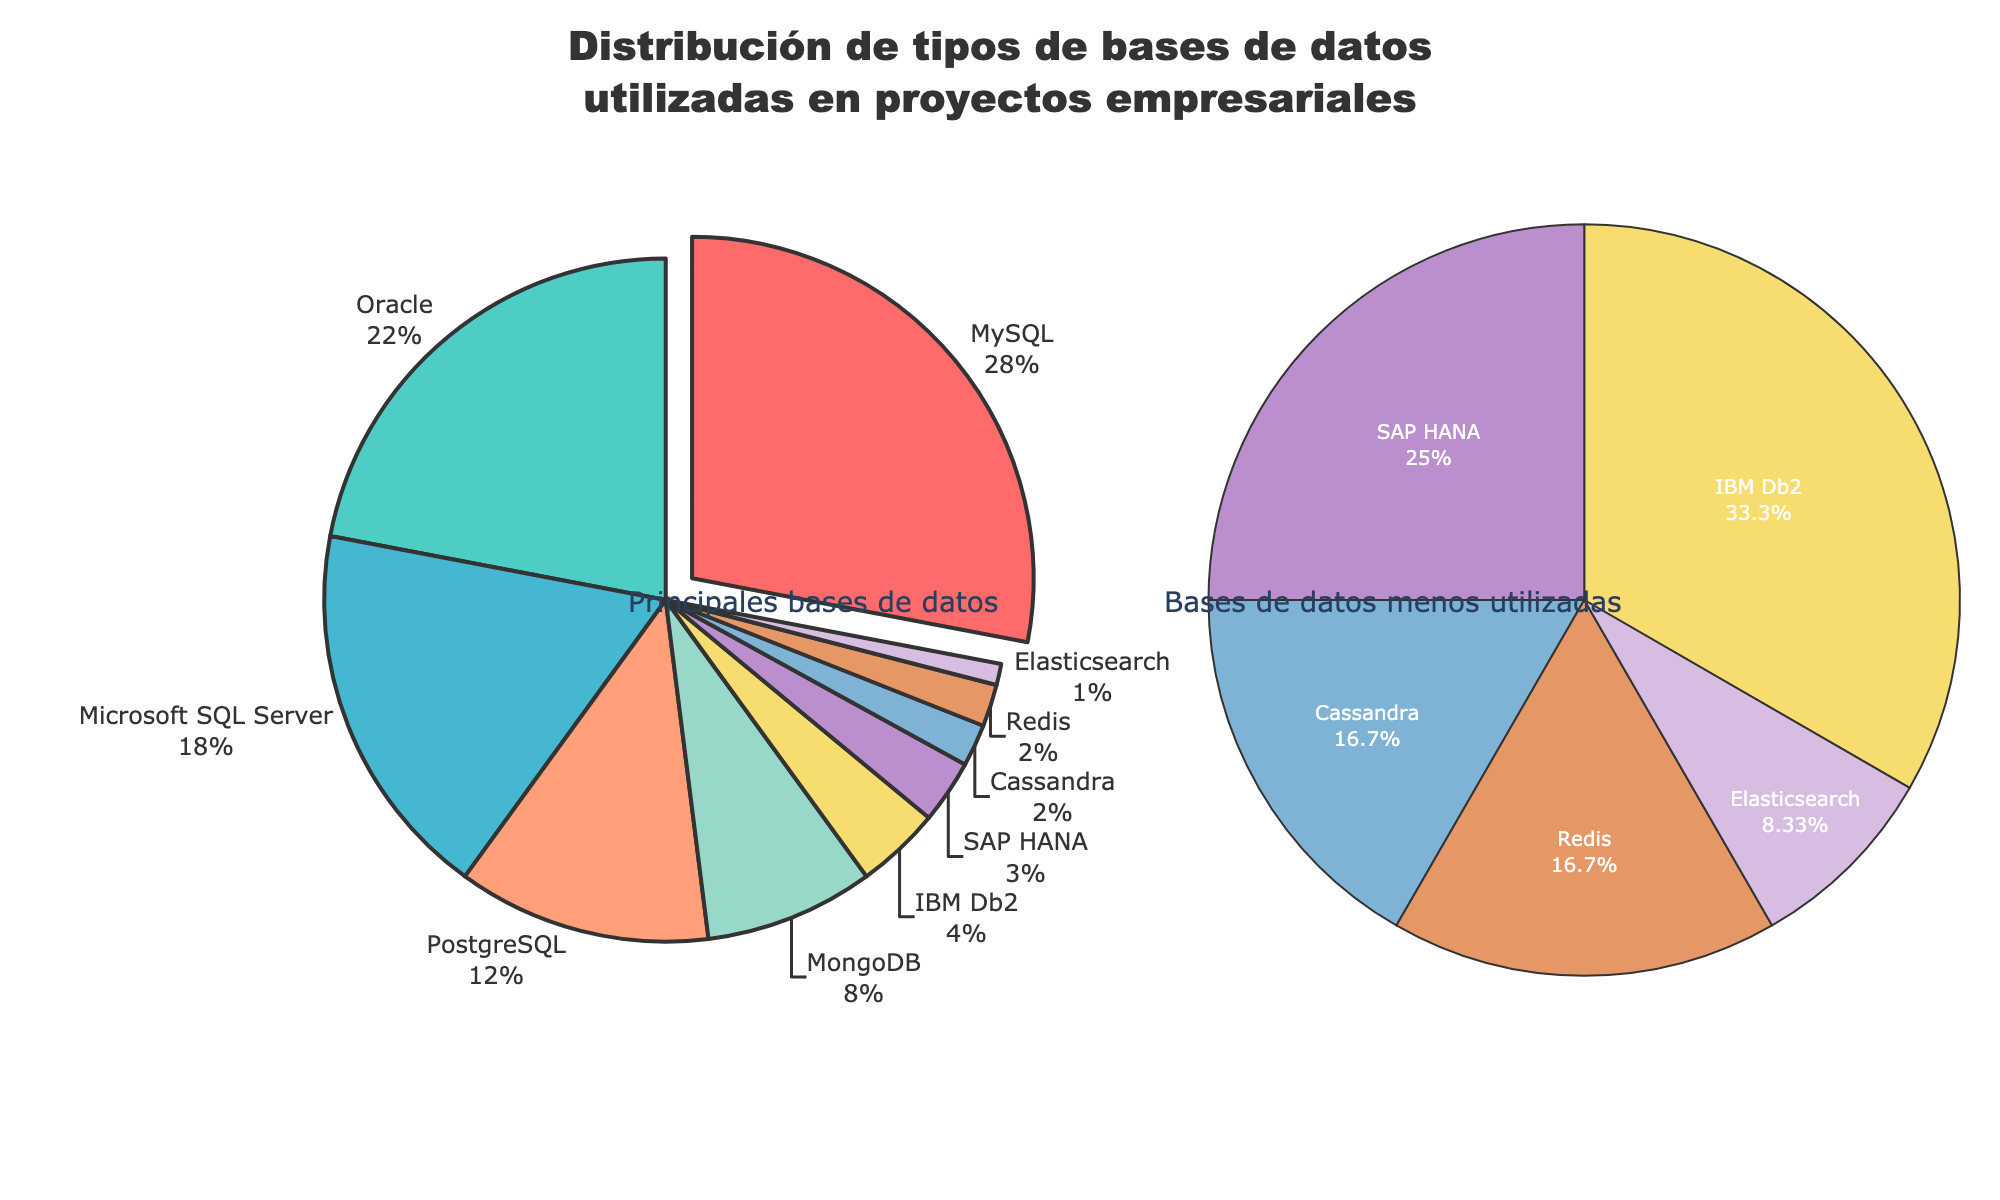¿Cuál es el tipo de base de datos más utilizado? Primero, observo los segmentos del gráfico de pastel. El segmento con mayor tamaño y una pequeña extracción es "MySQL". También se puede observar en la etiqueta que muestra "28%" que es el valor más alto.
Answer: MySQL ¿Cuál es la diferencia en el porcentaje de uso entre MySQL y Oracle? Busco los valores específicos en las etiquetas: MySQL tiene un 28% y Oracle un 22%. Luego, resto estos valores: 28 - 22.
Answer: 6% ¿Cuántos tipos de bases de datos tienen un porcentaje de uso menor al 5%? En el gráfico adicional de "Bases de datos menos utilizadas", cuento los segmentos. Los tipos de bases de datos con menos del 5% son: IBM Db2, SAP HANA, Cassandra, Redis y Elasticsearch, sumando un total de 5.
Answer: 5 ¿Cuál es el porcentaje de uso combinado de PostgreSQL y Microsoft SQL Server? Busco los porcentajes individuales de ambos en las etiquetas: PostgreSQL (12%) y Microsoft SQL Server (18%). Sumo estos valores: 12 + 18.
Answer: 30% ¿Cuál es el segundo tipo de base de datos menos utilizado? Observo el gráfico adicional. Después de Elasticsearch (1%), las siguientes bases de datos con menor porcentaje son Redis y Cassandra, ambas con un 2%. Por orden alfabético, Redis es el primero que encuentro.
Answer: Redis ¿Cuál es el total del porcentaje de uso de las tres principales bases de datos? Identifico las tres bases de datos con los mayores porcentajes: MySQL (28%), Oracle (22%) y Microsoft SQL Server (18%). Luego, sumo estos valores: 28 + 22 + 18.
Answer: 68% Comparando MongoDB y SAP HANA, ¿cuál tiene un mayor porcentaje de uso y por cuánto? Busco los valores de ambos: MongoDB (8%) y SAP HANA (3%). MongoDB tiene un mayor porcentaje de uso. La diferencia es 8 - 3.
Answer: MongoDB, 5% ¿Cuál es el porcentaje de uso total de las bases de datos no relacionales (NoSQL) en la figura principal? Identifico las bases de datos NoSQL: MongoDB (8%), Cassandra (2%) y Redis (2%). Luego, sumo estos valores: 8 + 2 + 2.
Answer: 12% Enumere todos los tipos de bases de datos que tienen un porcentaje de uso igual o mayor al 10%. Observo las etiquetas y selecciono las que cumplan la condición: MySQL (28%), Oracle (22%), Microsoft SQL Server (18%) y PostgreSQL (12%).
Answer: MySQL, Oracle, Microsoft SQL Server, PostgreSQL ¿Cómo se distribuye el uso entre las bases de datos relacionales y no relacionales en los gráficos? (Proporciones relativas en porcentaje) Identifico las bases de datos relacionales (MySQL, Oracle, Microsoft SQL Server, PostgreSQL, IBM Db2, SAP HANA) con porcentajes 28%, 22%, 18%, 12%, 4%, 3% respectivamente y sumo: 28 + 22 + 18 + 12 + 4 + 3 = 87%. Luego, identifico las bases de datos NoSQL (MongoDB, Cassandra, Redis, Elasticsearch) con porcentajes 8%, 2%, 2%, 1% respectivamente y sumo: 8 + 2 + 2 + 1 = 13%. Finalmente, divido estos sumas por el 100% para obtener las proporciones.
Answer: 87% relacionales, 13% NoSQL 